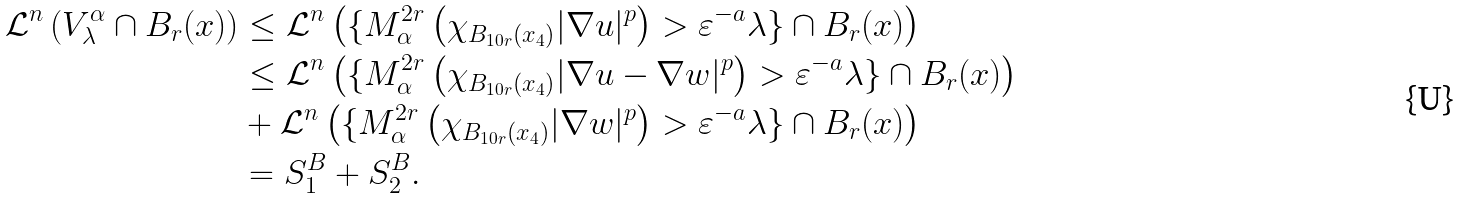Convert formula to latex. <formula><loc_0><loc_0><loc_500><loc_500>\mathcal { L } ^ { n } \left ( V _ { \lambda } ^ { \alpha } \cap B _ { r } ( x ) \right ) & \leq \mathcal { L } ^ { n } \left ( \{ { M } _ { \alpha } ^ { 2 r } \left ( \chi _ { B _ { 1 0 r } ( x _ { 4 } ) } | \nabla u | ^ { p } \right ) > \varepsilon ^ { - a } \lambda \} \cap B _ { r } ( x ) \right ) \\ & \leq \mathcal { L } ^ { n } \left ( \{ { M } _ { \alpha } ^ { 2 r } \left ( \chi _ { B _ { 1 0 r } ( x _ { 4 } ) } | \nabla u - \nabla w | ^ { p } \right ) > \varepsilon ^ { - a } \lambda \} \cap B _ { r } ( x ) \right ) \\ & + \mathcal { L } ^ { n } \left ( \{ { M } _ { \alpha } ^ { 2 r } \left ( \chi _ { B _ { 1 0 r } ( x _ { 4 } ) } | \nabla w | ^ { p } \right ) > \varepsilon ^ { - a } \lambda \} \cap B _ { r } ( x ) \right ) \\ & = S _ { 1 } ^ { B } + S _ { 2 } ^ { B } .</formula> 